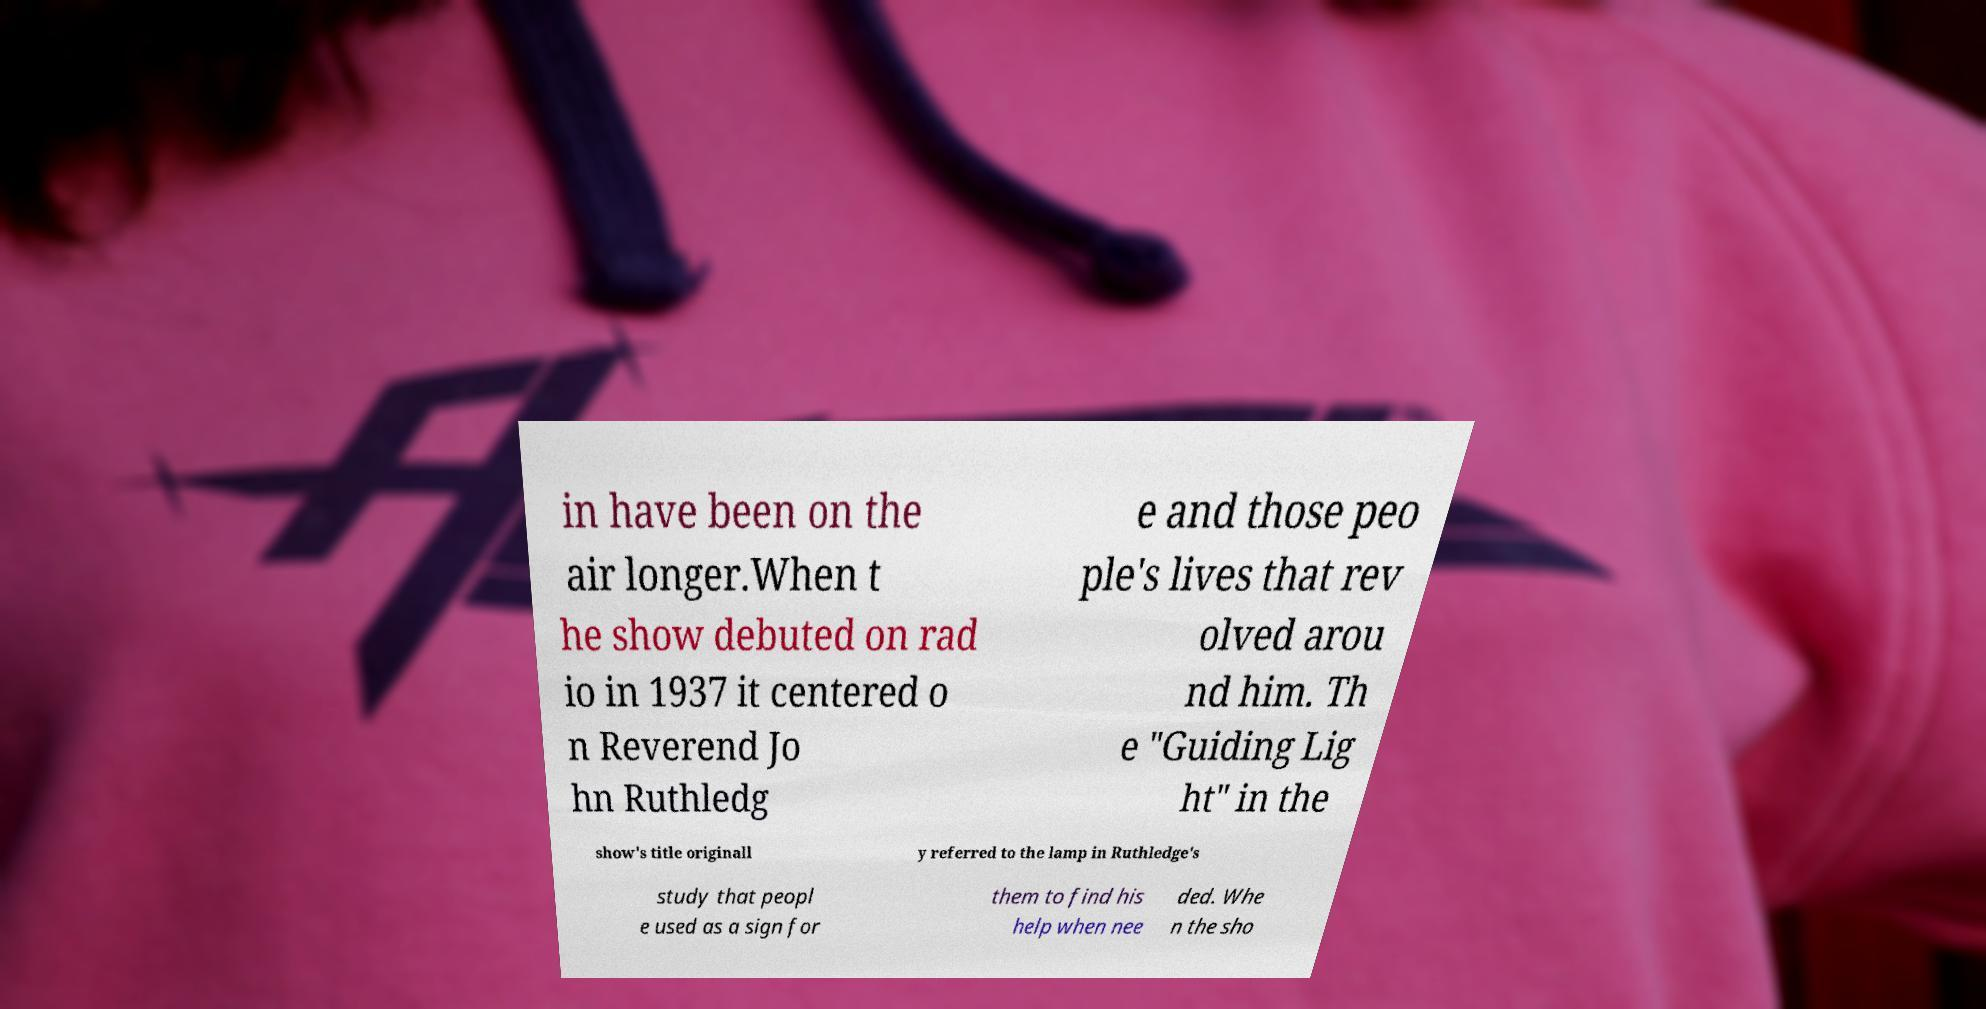Could you extract and type out the text from this image? in have been on the air longer.When t he show debuted on rad io in 1937 it centered o n Reverend Jo hn Ruthledg e and those peo ple's lives that rev olved arou nd him. Th e "Guiding Lig ht" in the show's title originall y referred to the lamp in Ruthledge's study that peopl e used as a sign for them to find his help when nee ded. Whe n the sho 